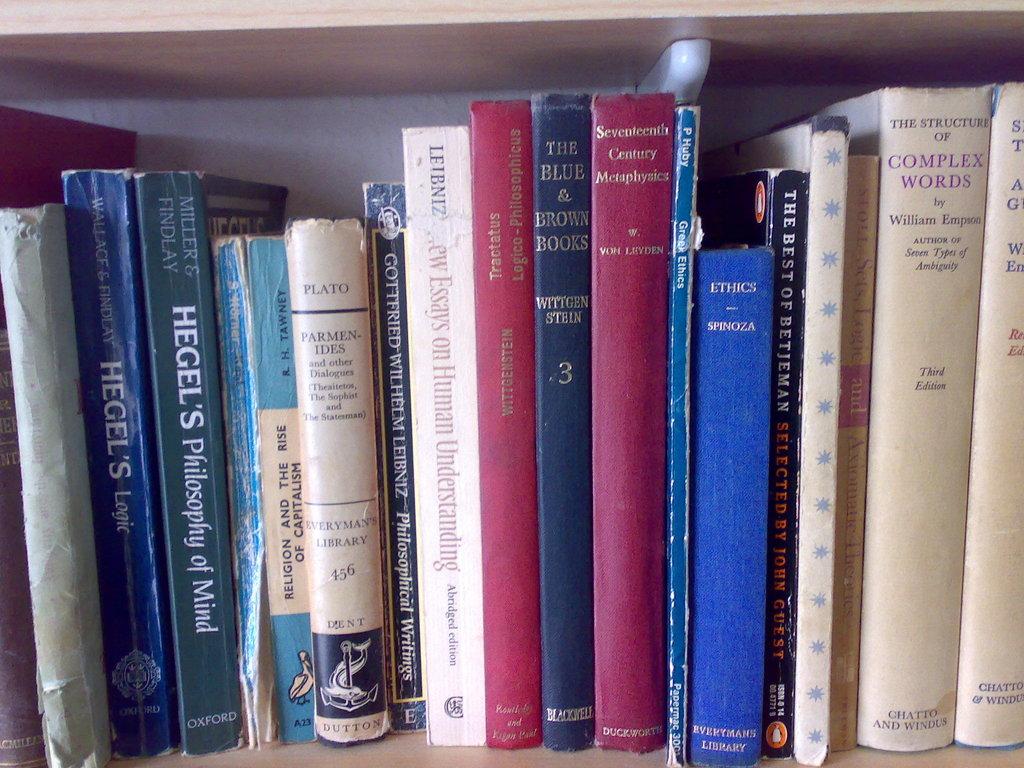Whats the title of the slim blue book in the middle of the two red books?
Give a very brief answer. The blue and brown books. 